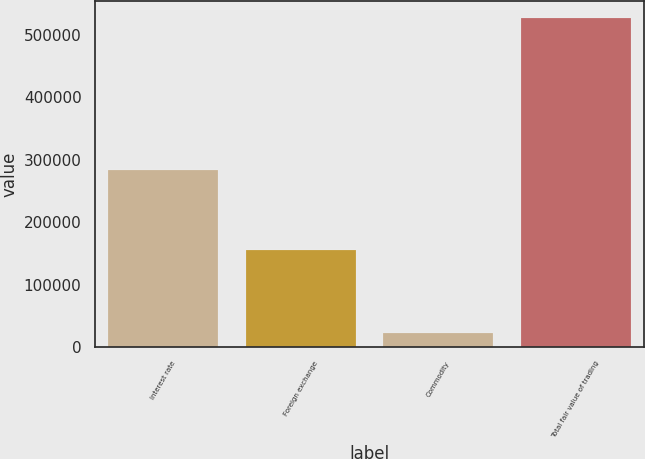<chart> <loc_0><loc_0><loc_500><loc_500><bar_chart><fcel>Interest rate<fcel>Foreign exchange<fcel>Commodity<fcel>Total fair value of trading<nl><fcel>283092<fcel>154601<fcel>21498<fcel>527838<nl></chart> 